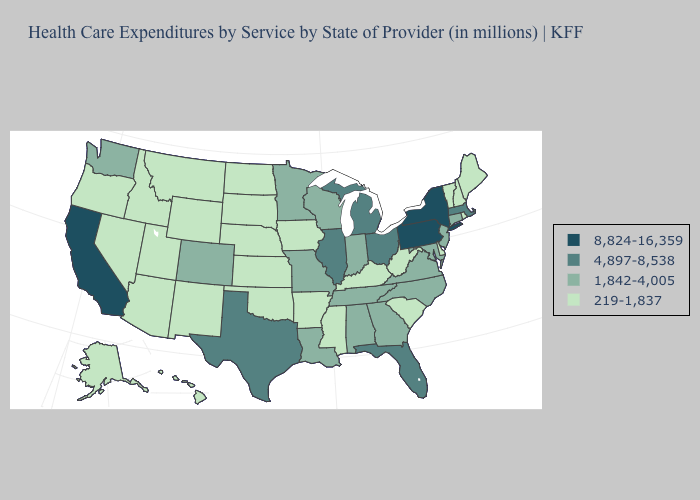What is the value of Utah?
Quick response, please. 219-1,837. Name the states that have a value in the range 8,824-16,359?
Give a very brief answer. California, New York, Pennsylvania. What is the value of Washington?
Answer briefly. 1,842-4,005. Does New York have the lowest value in the Northeast?
Keep it brief. No. Does Michigan have a higher value than Kansas?
Answer briefly. Yes. What is the value of Mississippi?
Keep it brief. 219-1,837. Which states hav the highest value in the South?
Short answer required. Florida, Texas. Which states hav the highest value in the Northeast?
Short answer required. New York, Pennsylvania. Is the legend a continuous bar?
Concise answer only. No. Name the states that have a value in the range 4,897-8,538?
Be succinct. Florida, Illinois, Massachusetts, Michigan, Ohio, Texas. What is the value of Arizona?
Write a very short answer. 219-1,837. What is the value of Idaho?
Quick response, please. 219-1,837. Does New York have the highest value in the USA?
Write a very short answer. Yes. Name the states that have a value in the range 219-1,837?
Keep it brief. Alaska, Arizona, Arkansas, Delaware, Hawaii, Idaho, Iowa, Kansas, Kentucky, Maine, Mississippi, Montana, Nebraska, Nevada, New Hampshire, New Mexico, North Dakota, Oklahoma, Oregon, Rhode Island, South Carolina, South Dakota, Utah, Vermont, West Virginia, Wyoming. Which states have the highest value in the USA?
Write a very short answer. California, New York, Pennsylvania. 